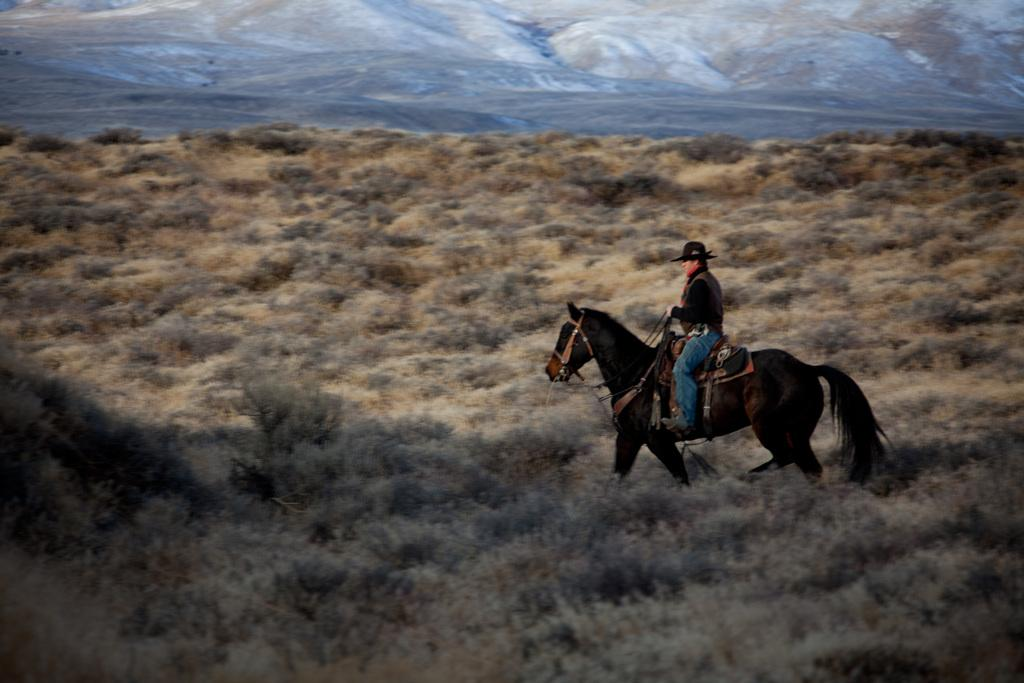Who is the main subject in the image? There is a man in the image. What is the man doing in the image? The man is riding a horse. Where are the horse and rider located? They are in a field. What can be seen in the distance in the image? There are hills visible in the background of the image. What route is the man taking on the horse, and how many clocks are present in the image? There is no information about the route the man is taking on the horse, and no clocks are present in the image. 